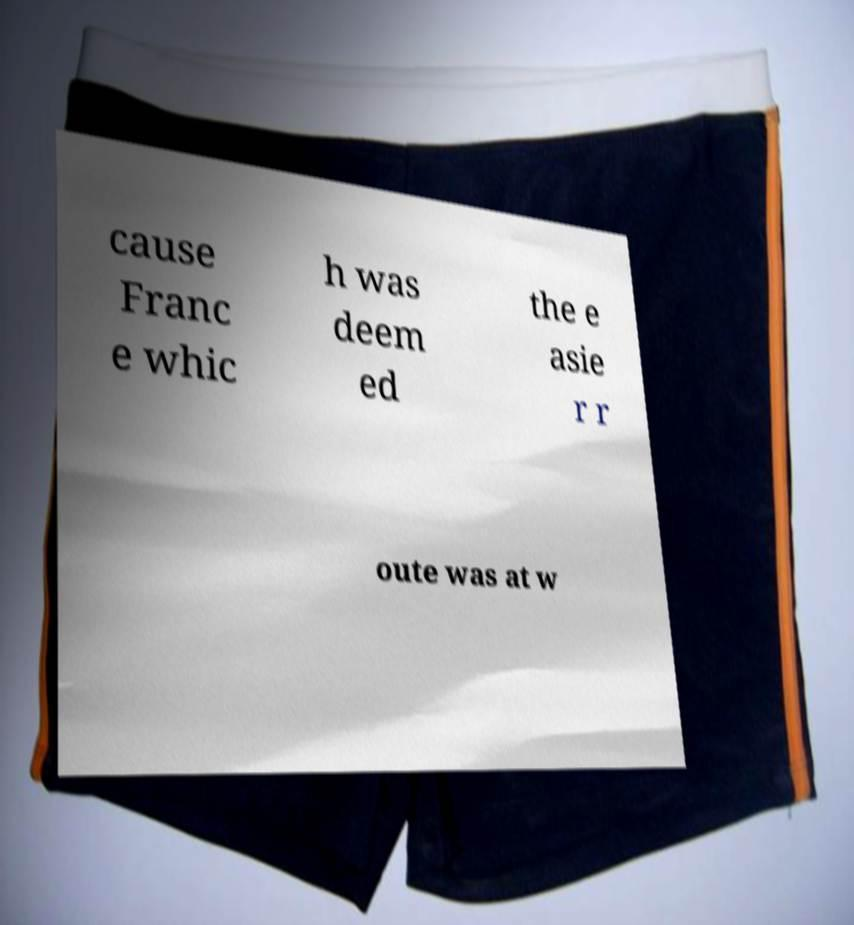I need the written content from this picture converted into text. Can you do that? cause Franc e whic h was deem ed the e asie r r oute was at w 